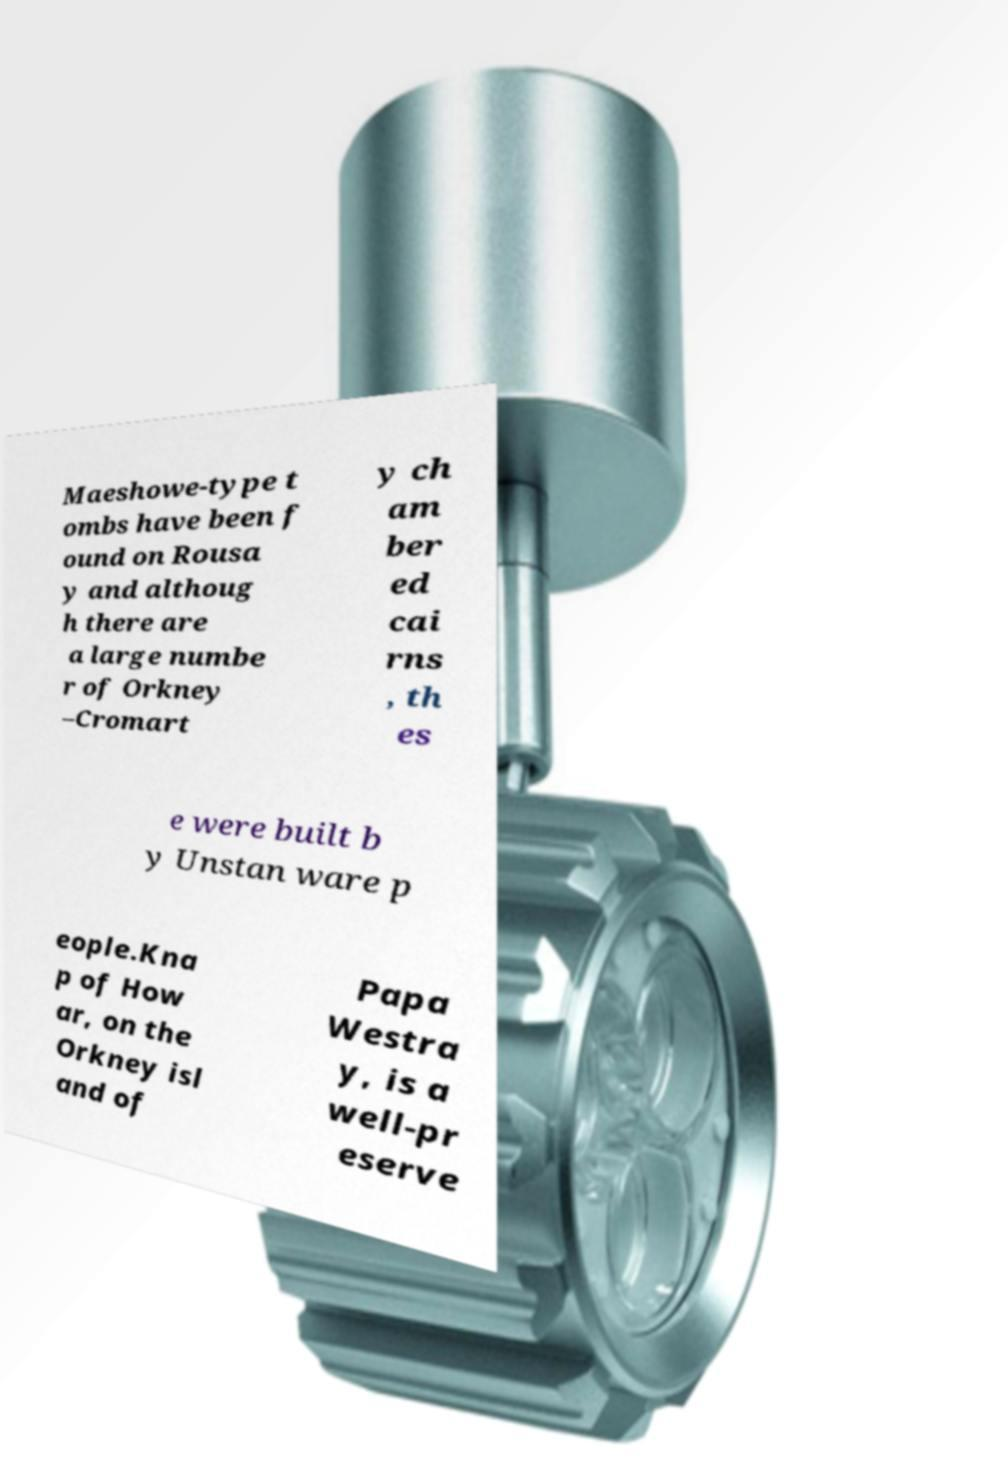Can you read and provide the text displayed in the image?This photo seems to have some interesting text. Can you extract and type it out for me? Maeshowe-type t ombs have been f ound on Rousa y and althoug h there are a large numbe r of Orkney –Cromart y ch am ber ed cai rns , th es e were built b y Unstan ware p eople.Kna p of How ar, on the Orkney isl and of Papa Westra y, is a well-pr eserve 